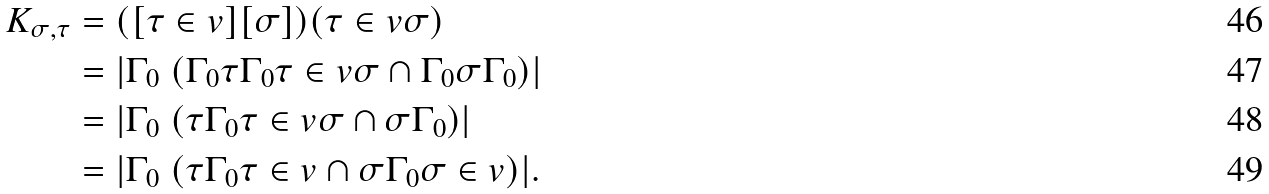Convert formula to latex. <formula><loc_0><loc_0><loc_500><loc_500>K _ { \sigma , \tau } & = ( [ \tau \in v ] [ \sigma ] ) ( \tau \in v \sigma ) \\ & = | \Gamma _ { 0 } \ ( \Gamma _ { 0 } \tau \Gamma _ { 0 } \tau \in v \sigma \cap \Gamma _ { 0 } \sigma \Gamma _ { 0 } ) | \\ & = | \Gamma _ { 0 } \ ( \tau \Gamma _ { 0 } \tau \in v \sigma \cap \sigma \Gamma _ { 0 } ) | \\ & = | \Gamma _ { 0 } \ ( \tau \Gamma _ { 0 } \tau \in v \cap \sigma \Gamma _ { 0 } \sigma \in v ) | .</formula> 